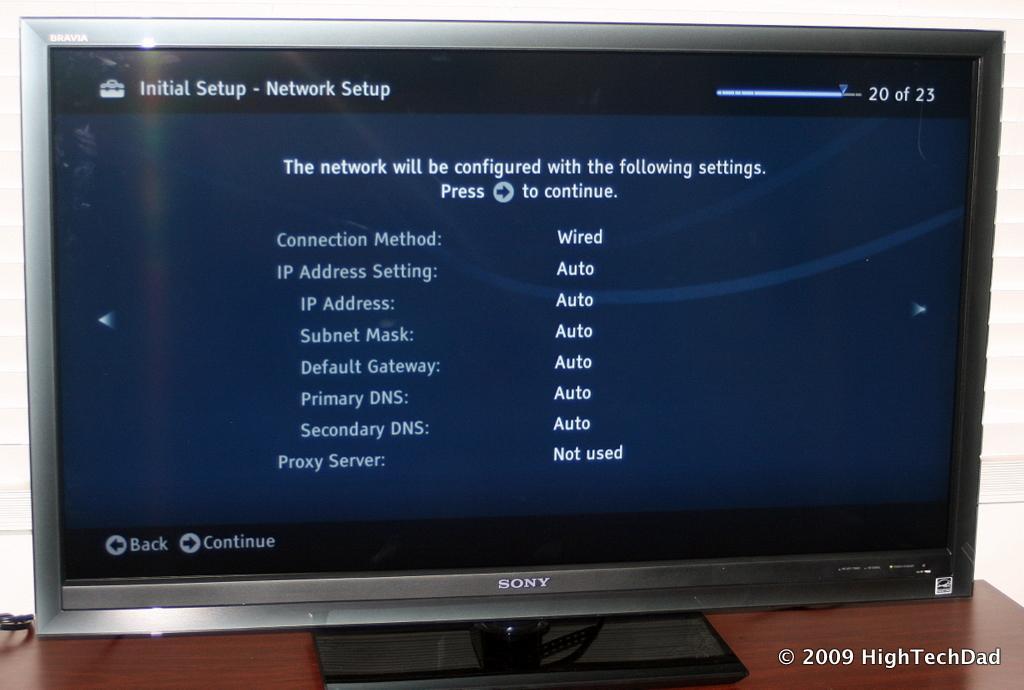Can you describe this image briefly? In this image there is a monitor with some text on it, the monitor is on top of the table, behind the monitor there is a cable and a curtain, at the bottom of the image there is some text. 